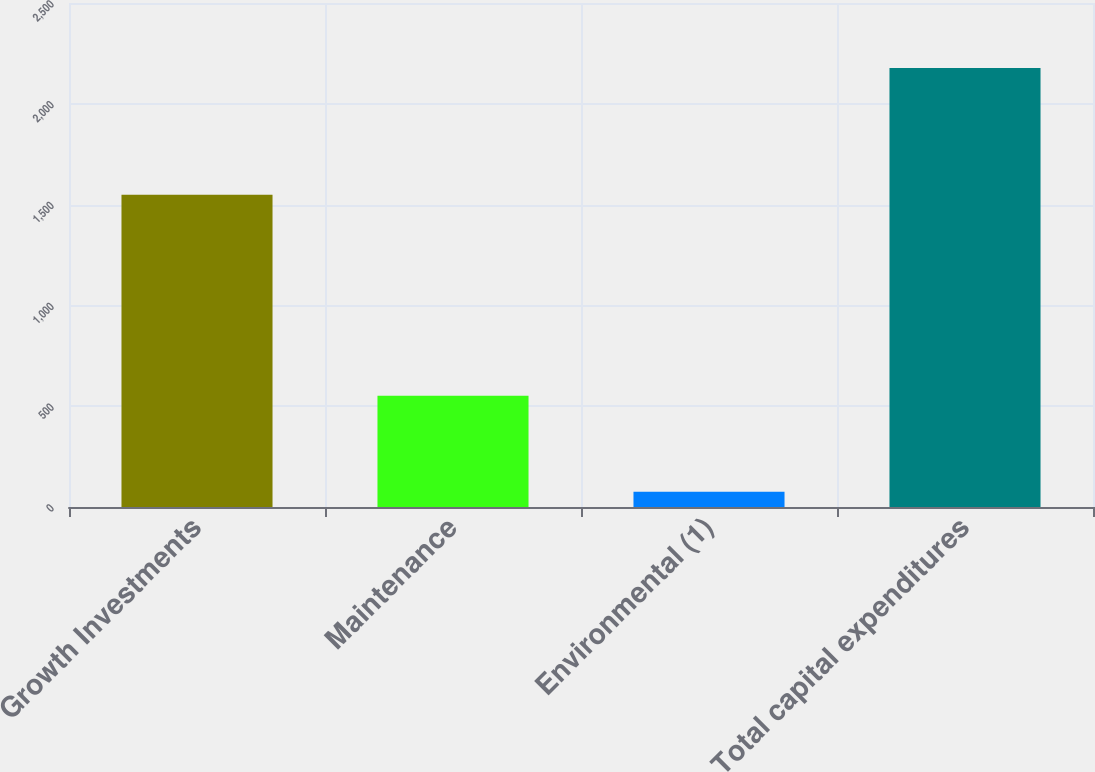Convert chart. <chart><loc_0><loc_0><loc_500><loc_500><bar_chart><fcel>Growth Investments<fcel>Maintenance<fcel>Environmental (1)<fcel>Total capital expenditures<nl><fcel>1549<fcel>552<fcel>76<fcel>2177<nl></chart> 